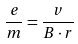<formula> <loc_0><loc_0><loc_500><loc_500>\frac { e } { m } = \frac { v } { B \cdot r }</formula> 